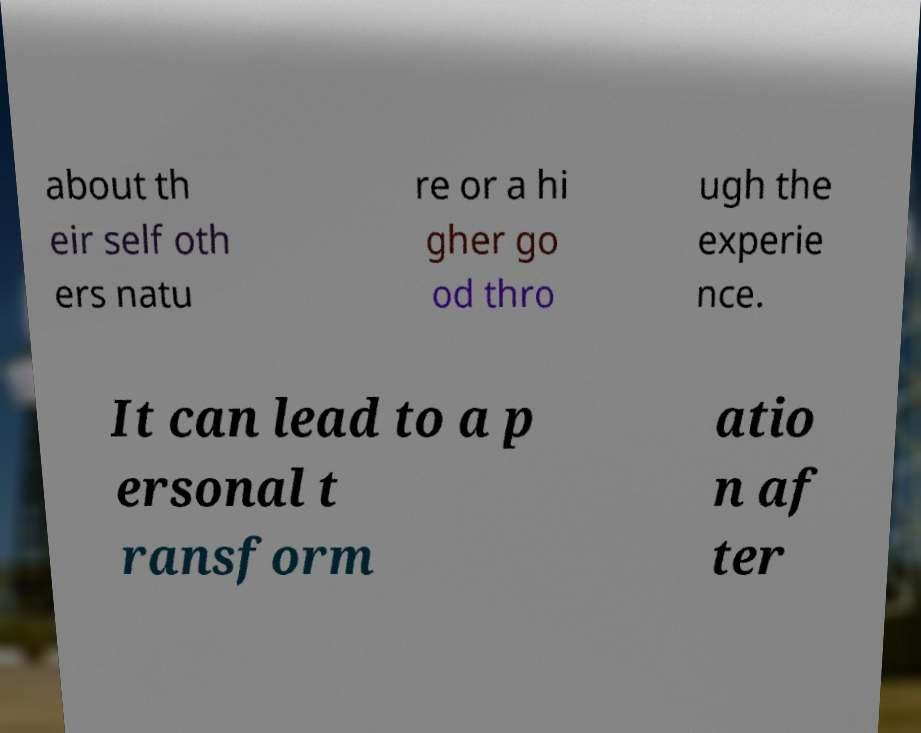For documentation purposes, I need the text within this image transcribed. Could you provide that? about th eir self oth ers natu re or a hi gher go od thro ugh the experie nce. It can lead to a p ersonal t ransform atio n af ter 